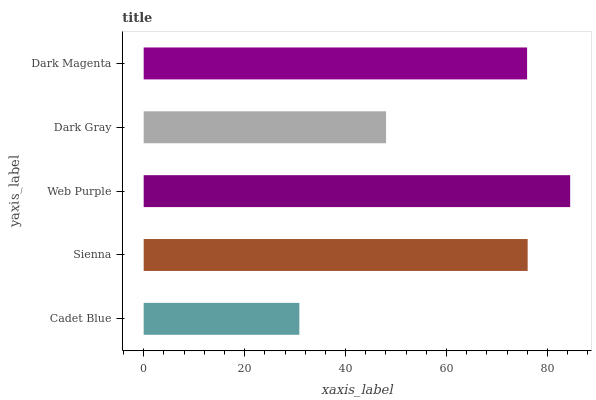Is Cadet Blue the minimum?
Answer yes or no. Yes. Is Web Purple the maximum?
Answer yes or no. Yes. Is Sienna the minimum?
Answer yes or no. No. Is Sienna the maximum?
Answer yes or no. No. Is Sienna greater than Cadet Blue?
Answer yes or no. Yes. Is Cadet Blue less than Sienna?
Answer yes or no. Yes. Is Cadet Blue greater than Sienna?
Answer yes or no. No. Is Sienna less than Cadet Blue?
Answer yes or no. No. Is Dark Magenta the high median?
Answer yes or no. Yes. Is Dark Magenta the low median?
Answer yes or no. Yes. Is Sienna the high median?
Answer yes or no. No. Is Web Purple the low median?
Answer yes or no. No. 